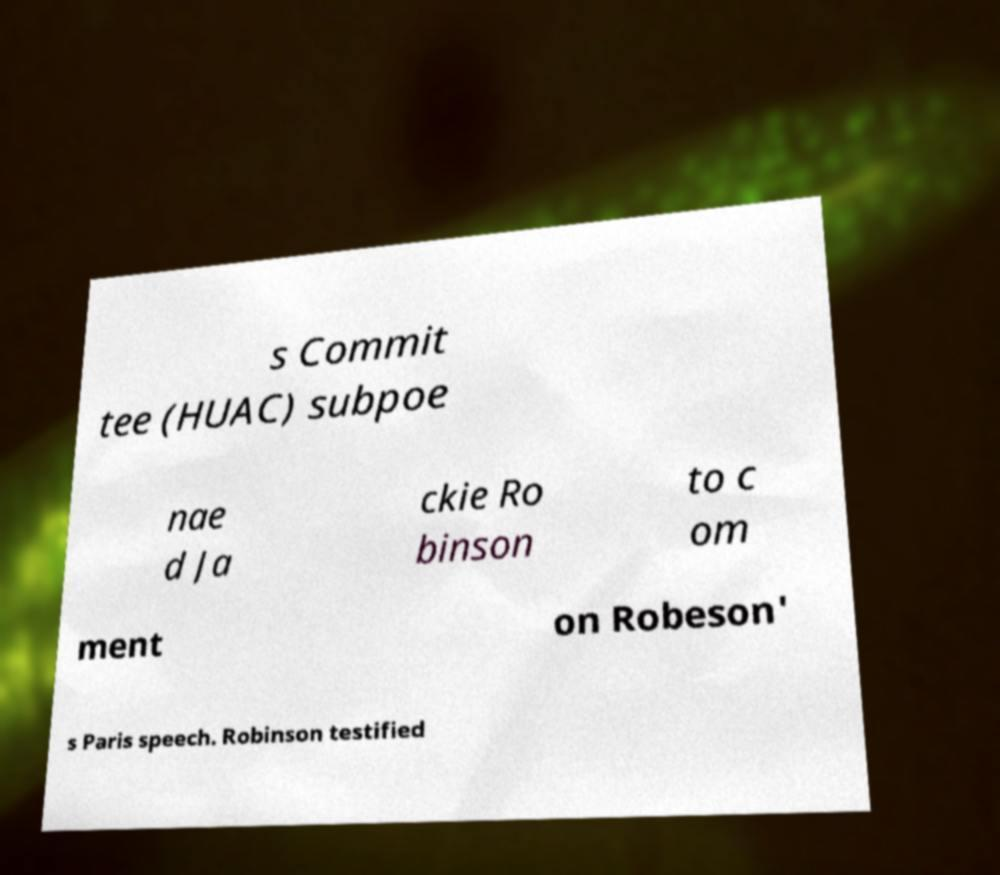Could you extract and type out the text from this image? s Commit tee (HUAC) subpoe nae d Ja ckie Ro binson to c om ment on Robeson' s Paris speech. Robinson testified 